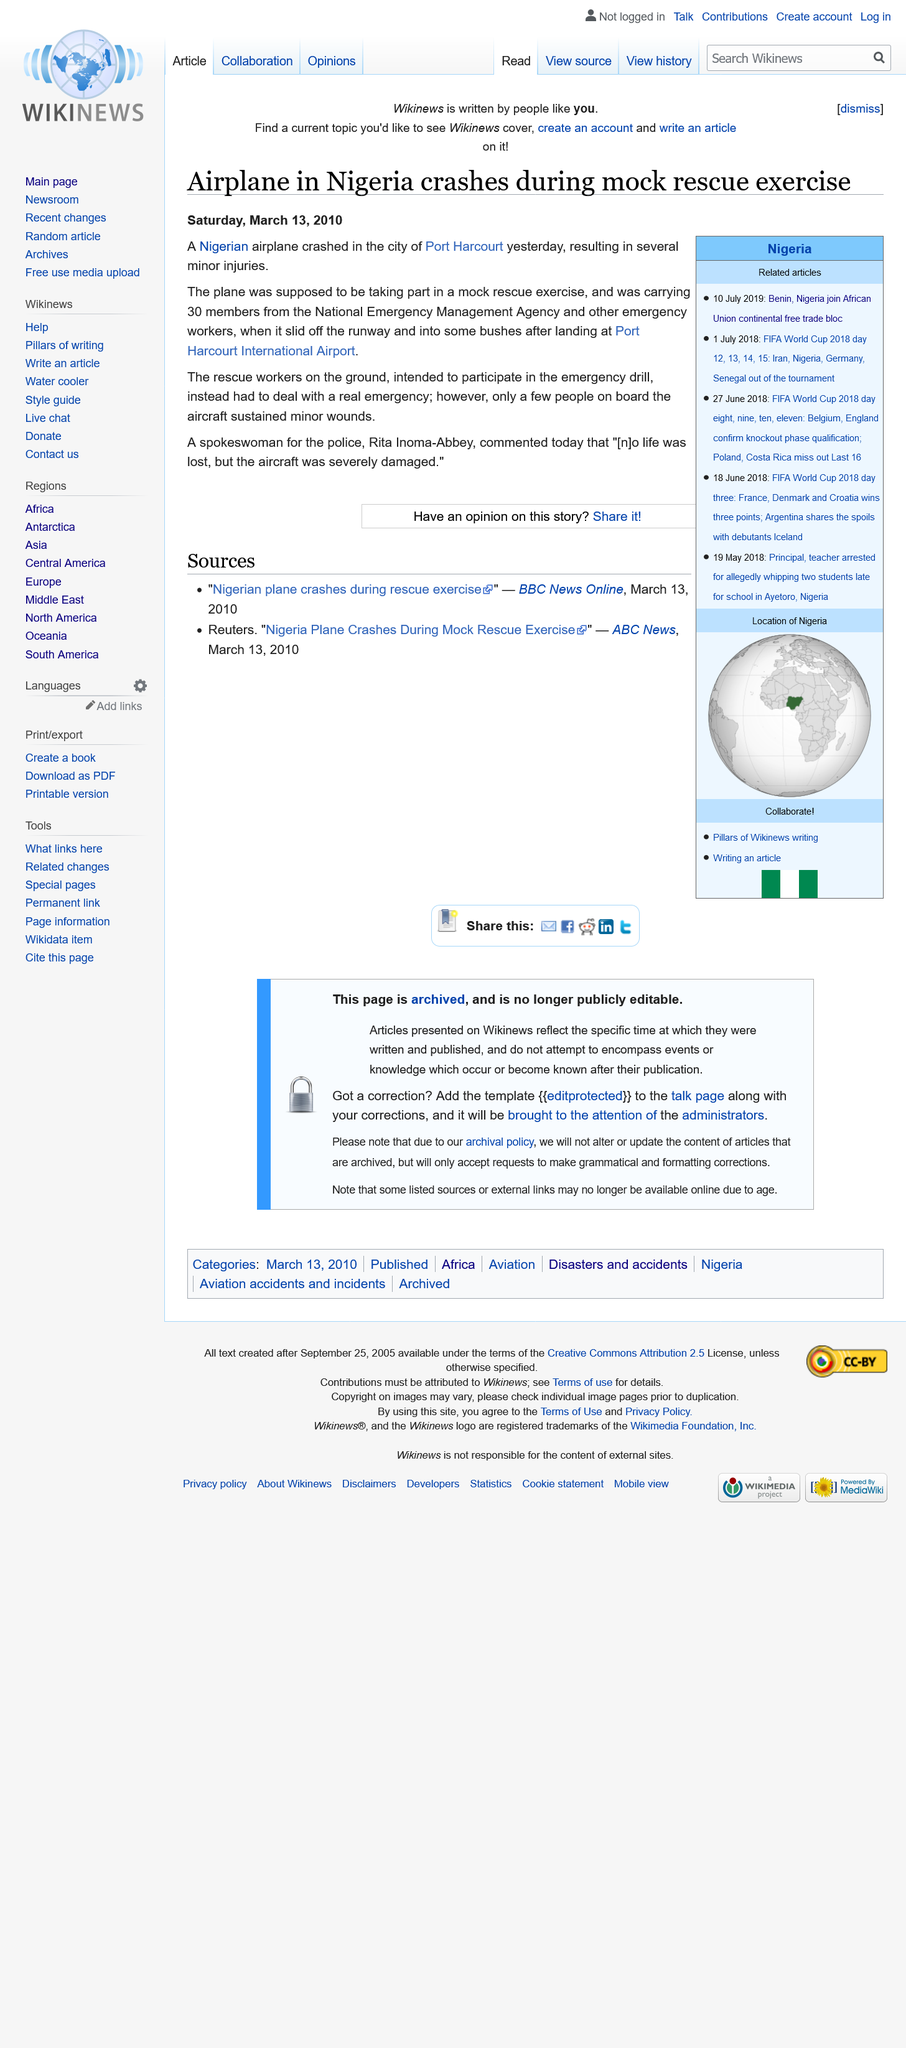Give some essential details in this illustration. Thirty members of the National Emergency Management Agency were on the plane. The report regarding the crash of the Nigerian airplane, which occurred on Saturday, March 13, 2010, is dated. The plane crashed at the Port Harcourt International Airport. 